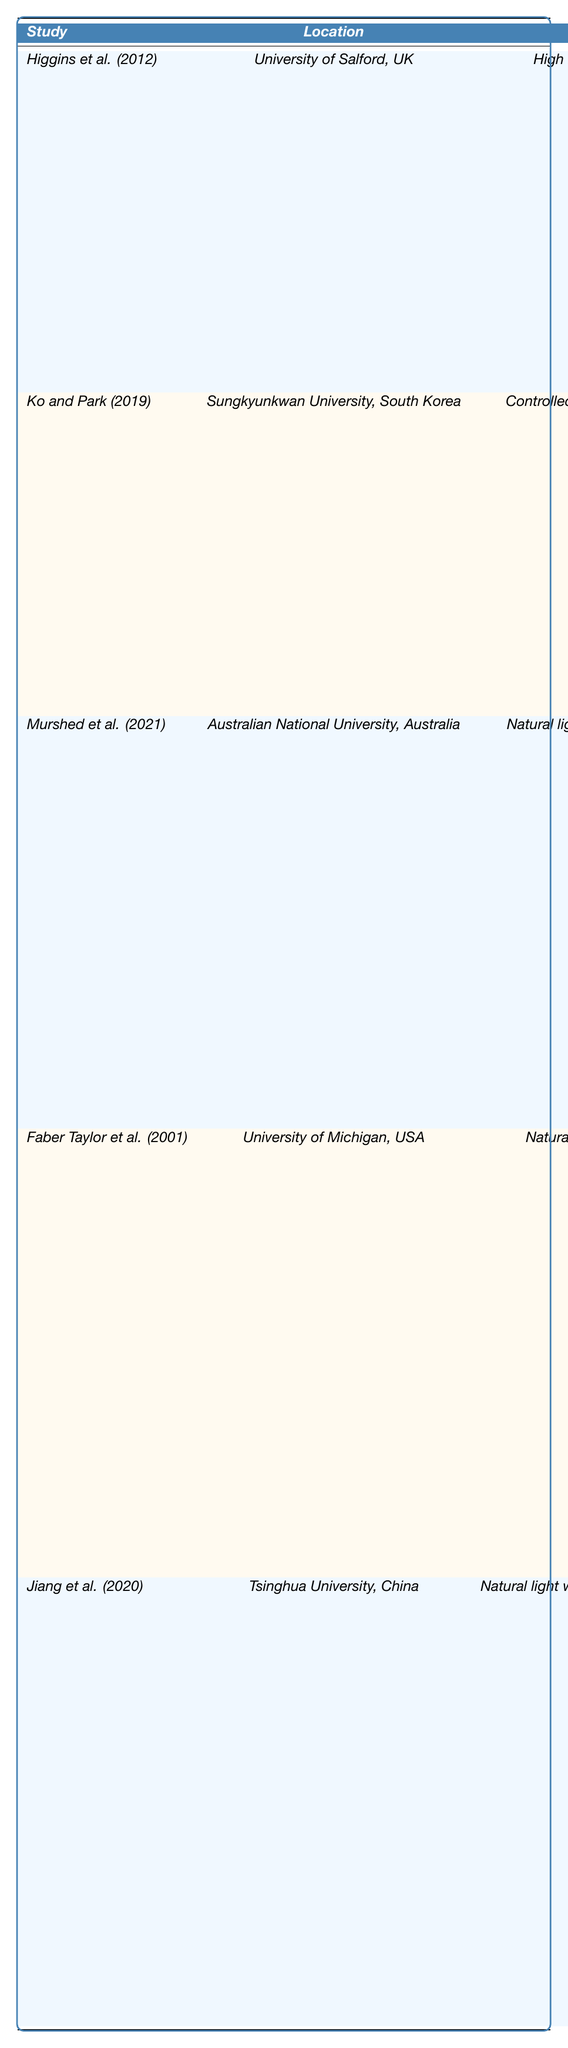What percentage change in cognitive performance was reported by Faber Taylor et al. (2001)? The table shows that Faber Taylor et al. (2001) reported a percentage change of 30% in cognitive performance.
Answer: 30% Which study reported the highest percentage change in cognitive performance due to natural light? By comparing the percentage changes listed, Murshed et al. (2021) reported the highest percentage change of 25%.
Answer: 25% Did Jiang et al. (2020) find that natural light improved problem-solving skills? The table indicates that Jiang et al. (2020) reported better problem-solving skills due to mixed natural and artificial light, so the answer is yes.
Answer: Yes What is the average percentage change in cognitive performance reported across all studies? To find the average, sum the percentage changes: 20% + 15% + 25% + 30% + 10% = 100%. There are 5 studies, so the average is 100% / 5 = 20%.
Answer: 20% Which location had the study with controlled natural light, and what was the impact on cognitive performance? The study by Ko and Park (2019) at Sungkyunkwan University, South Korea, used controlled natural light via skylights and reported a 15% enhancement in attention span.
Answer: Sungkyunkwan University, 15% What cognitive performance metric was improved by the most studies? The metrics can be compared: improved test scores, enhanced attention span, higher engagement levels, increased memory retention, and better problem-solving skills. Among these, engagement and memory retention are notable but the highest is a range of metrics reported separately across studies, making it unclear if some overlap exists.
Answer: Not specifically measurable from this data Did any studies report a percentage change lower than 15%? By reviewing the table, only Jiang et al. (2020) reported a 10% change, which is below 15%.
Answer: Yes Which study associated natural light exposure with support from views of greenery? The data indicates that Murshed et al. (2021) associated natural light exposure with views of greenery and reported a 25% increase in engagement levels.
Answer: Murshed et al. (2021) 